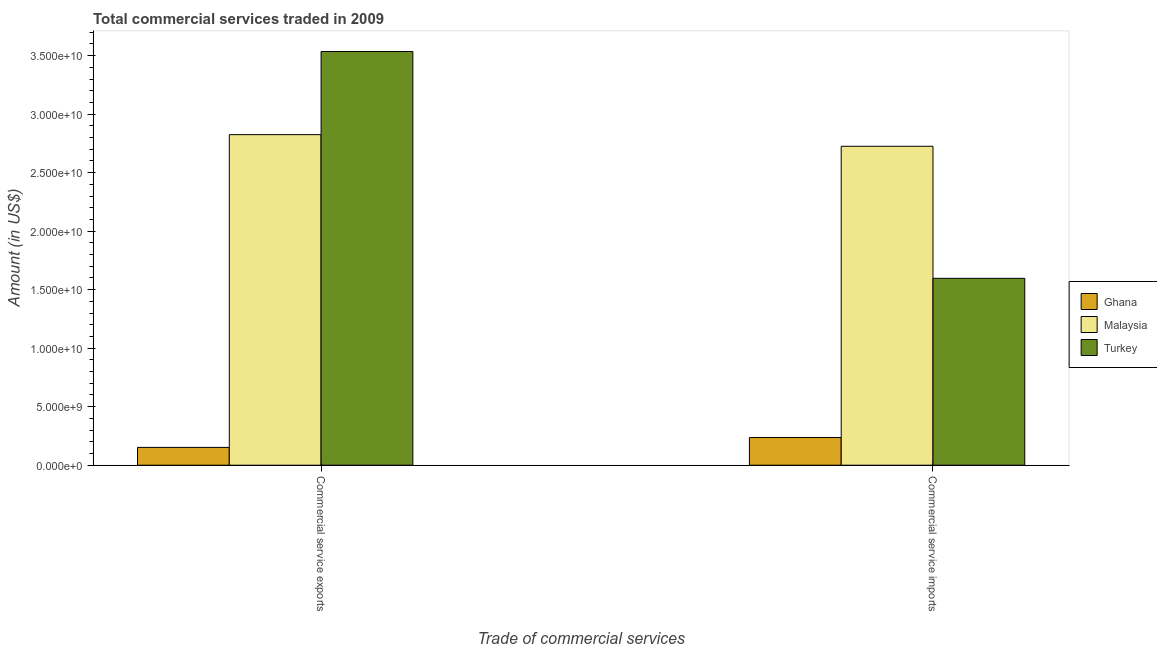Are the number of bars on each tick of the X-axis equal?
Provide a short and direct response. Yes. How many bars are there on the 2nd tick from the left?
Your response must be concise. 3. How many bars are there on the 2nd tick from the right?
Your answer should be very brief. 3. What is the label of the 2nd group of bars from the left?
Make the answer very short. Commercial service imports. What is the amount of commercial service imports in Turkey?
Keep it short and to the point. 1.60e+1. Across all countries, what is the maximum amount of commercial service exports?
Keep it short and to the point. 3.54e+1. Across all countries, what is the minimum amount of commercial service imports?
Ensure brevity in your answer.  2.37e+09. In which country was the amount of commercial service imports maximum?
Give a very brief answer. Malaysia. What is the total amount of commercial service imports in the graph?
Your answer should be compact. 4.56e+1. What is the difference between the amount of commercial service imports in Turkey and that in Ghana?
Offer a terse response. 1.36e+1. What is the difference between the amount of commercial service imports in Turkey and the amount of commercial service exports in Ghana?
Give a very brief answer. 1.44e+1. What is the average amount of commercial service imports per country?
Your answer should be very brief. 1.52e+1. What is the difference between the amount of commercial service imports and amount of commercial service exports in Ghana?
Make the answer very short. 8.44e+08. What is the ratio of the amount of commercial service exports in Malaysia to that in Turkey?
Keep it short and to the point. 0.8. Is the amount of commercial service imports in Malaysia less than that in Ghana?
Provide a succinct answer. No. What does the 2nd bar from the left in Commercial service imports represents?
Your answer should be compact. Malaysia. Does the graph contain any zero values?
Provide a short and direct response. No. Does the graph contain grids?
Your answer should be very brief. No. Where does the legend appear in the graph?
Your response must be concise. Center right. How are the legend labels stacked?
Provide a short and direct response. Vertical. What is the title of the graph?
Ensure brevity in your answer.  Total commercial services traded in 2009. Does "Curacao" appear as one of the legend labels in the graph?
Your response must be concise. No. What is the label or title of the X-axis?
Your response must be concise. Trade of commercial services. What is the label or title of the Y-axis?
Offer a very short reply. Amount (in US$). What is the Amount (in US$) of Ghana in Commercial service exports?
Offer a very short reply. 1.52e+09. What is the Amount (in US$) of Malaysia in Commercial service exports?
Your answer should be very brief. 2.82e+1. What is the Amount (in US$) in Turkey in Commercial service exports?
Provide a short and direct response. 3.54e+1. What is the Amount (in US$) in Ghana in Commercial service imports?
Keep it short and to the point. 2.37e+09. What is the Amount (in US$) of Malaysia in Commercial service imports?
Offer a very short reply. 2.73e+1. What is the Amount (in US$) in Turkey in Commercial service imports?
Your answer should be very brief. 1.60e+1. Across all Trade of commercial services, what is the maximum Amount (in US$) in Ghana?
Your answer should be compact. 2.37e+09. Across all Trade of commercial services, what is the maximum Amount (in US$) of Malaysia?
Give a very brief answer. 2.82e+1. Across all Trade of commercial services, what is the maximum Amount (in US$) of Turkey?
Ensure brevity in your answer.  3.54e+1. Across all Trade of commercial services, what is the minimum Amount (in US$) of Ghana?
Provide a succinct answer. 1.52e+09. Across all Trade of commercial services, what is the minimum Amount (in US$) in Malaysia?
Keep it short and to the point. 2.73e+1. Across all Trade of commercial services, what is the minimum Amount (in US$) in Turkey?
Provide a succinct answer. 1.60e+1. What is the total Amount (in US$) of Ghana in the graph?
Ensure brevity in your answer.  3.89e+09. What is the total Amount (in US$) in Malaysia in the graph?
Provide a short and direct response. 5.55e+1. What is the total Amount (in US$) of Turkey in the graph?
Provide a succinct answer. 5.13e+1. What is the difference between the Amount (in US$) of Ghana in Commercial service exports and that in Commercial service imports?
Provide a succinct answer. -8.44e+08. What is the difference between the Amount (in US$) of Malaysia in Commercial service exports and that in Commercial service imports?
Ensure brevity in your answer.  9.93e+08. What is the difference between the Amount (in US$) of Turkey in Commercial service exports and that in Commercial service imports?
Ensure brevity in your answer.  1.94e+1. What is the difference between the Amount (in US$) in Ghana in Commercial service exports and the Amount (in US$) in Malaysia in Commercial service imports?
Make the answer very short. -2.57e+1. What is the difference between the Amount (in US$) in Ghana in Commercial service exports and the Amount (in US$) in Turkey in Commercial service imports?
Provide a succinct answer. -1.44e+1. What is the difference between the Amount (in US$) of Malaysia in Commercial service exports and the Amount (in US$) of Turkey in Commercial service imports?
Your answer should be compact. 1.23e+1. What is the average Amount (in US$) in Ghana per Trade of commercial services?
Your response must be concise. 1.94e+09. What is the average Amount (in US$) in Malaysia per Trade of commercial services?
Ensure brevity in your answer.  2.78e+1. What is the average Amount (in US$) in Turkey per Trade of commercial services?
Offer a terse response. 2.57e+1. What is the difference between the Amount (in US$) in Ghana and Amount (in US$) in Malaysia in Commercial service exports?
Give a very brief answer. -2.67e+1. What is the difference between the Amount (in US$) in Ghana and Amount (in US$) in Turkey in Commercial service exports?
Give a very brief answer. -3.38e+1. What is the difference between the Amount (in US$) of Malaysia and Amount (in US$) of Turkey in Commercial service exports?
Your response must be concise. -7.11e+09. What is the difference between the Amount (in US$) of Ghana and Amount (in US$) of Malaysia in Commercial service imports?
Your answer should be very brief. -2.49e+1. What is the difference between the Amount (in US$) in Ghana and Amount (in US$) in Turkey in Commercial service imports?
Offer a terse response. -1.36e+1. What is the difference between the Amount (in US$) of Malaysia and Amount (in US$) of Turkey in Commercial service imports?
Your response must be concise. 1.13e+1. What is the ratio of the Amount (in US$) of Ghana in Commercial service exports to that in Commercial service imports?
Keep it short and to the point. 0.64. What is the ratio of the Amount (in US$) in Malaysia in Commercial service exports to that in Commercial service imports?
Your answer should be compact. 1.04. What is the ratio of the Amount (in US$) of Turkey in Commercial service exports to that in Commercial service imports?
Provide a succinct answer. 2.21. What is the difference between the highest and the second highest Amount (in US$) of Ghana?
Your response must be concise. 8.44e+08. What is the difference between the highest and the second highest Amount (in US$) in Malaysia?
Offer a terse response. 9.93e+08. What is the difference between the highest and the second highest Amount (in US$) in Turkey?
Offer a very short reply. 1.94e+1. What is the difference between the highest and the lowest Amount (in US$) of Ghana?
Provide a succinct answer. 8.44e+08. What is the difference between the highest and the lowest Amount (in US$) in Malaysia?
Keep it short and to the point. 9.93e+08. What is the difference between the highest and the lowest Amount (in US$) of Turkey?
Your response must be concise. 1.94e+1. 